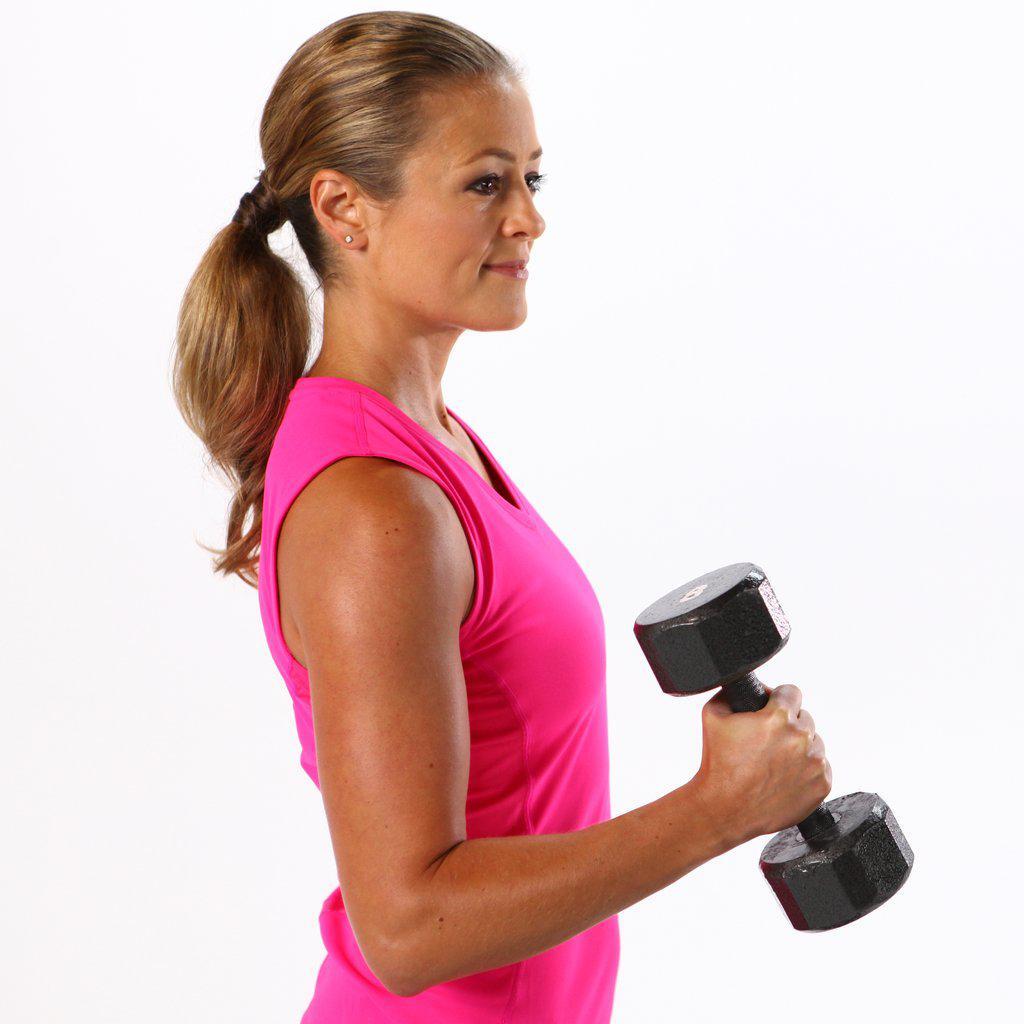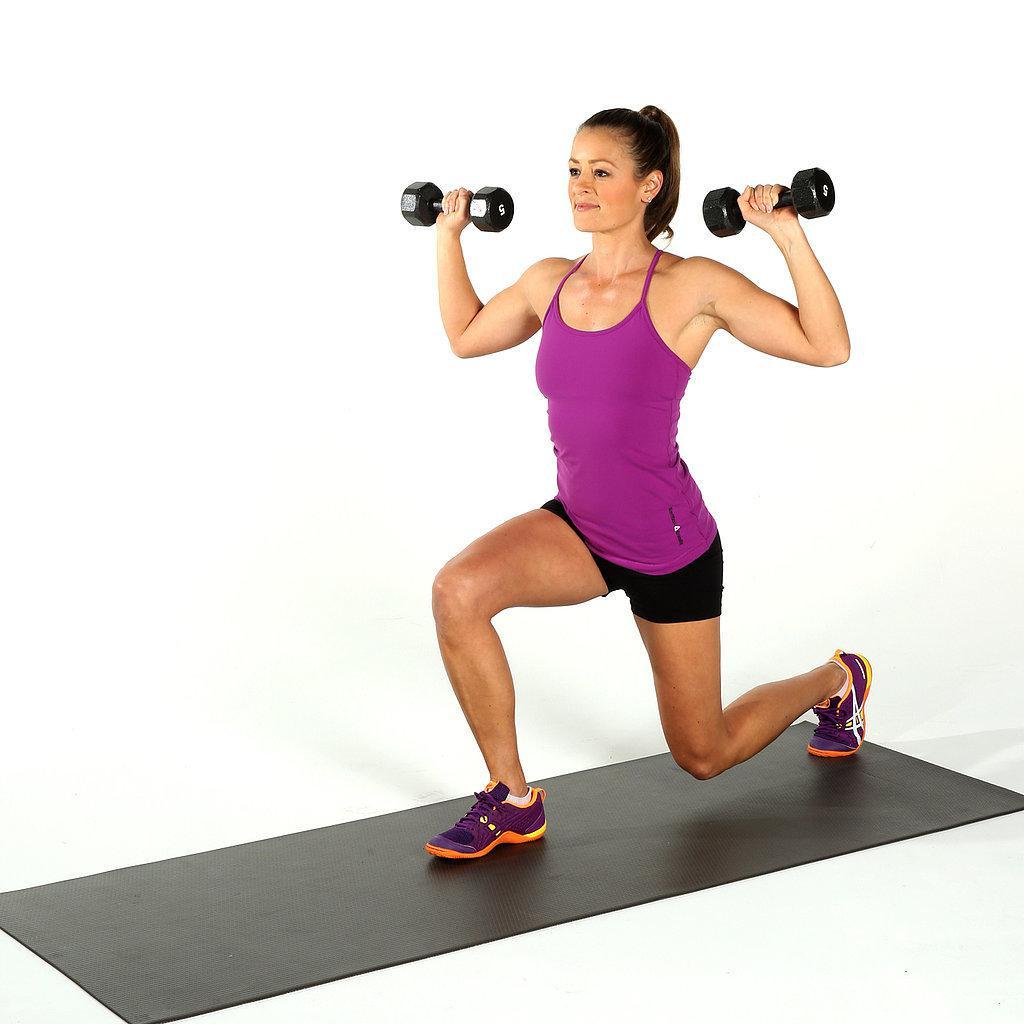The first image is the image on the left, the second image is the image on the right. For the images shown, is this caption "In the right image a woman is standing but kneeling towards the ground with one knee close to the floor." true? Answer yes or no. Yes. 